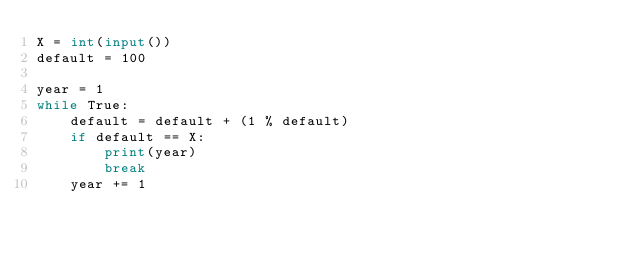Convert code to text. <code><loc_0><loc_0><loc_500><loc_500><_Python_>X = int(input())
default = 100

year = 1
while True:
    default = default + (1 % default)
    if default == X:
        print(year)
        break
    year += 1</code> 